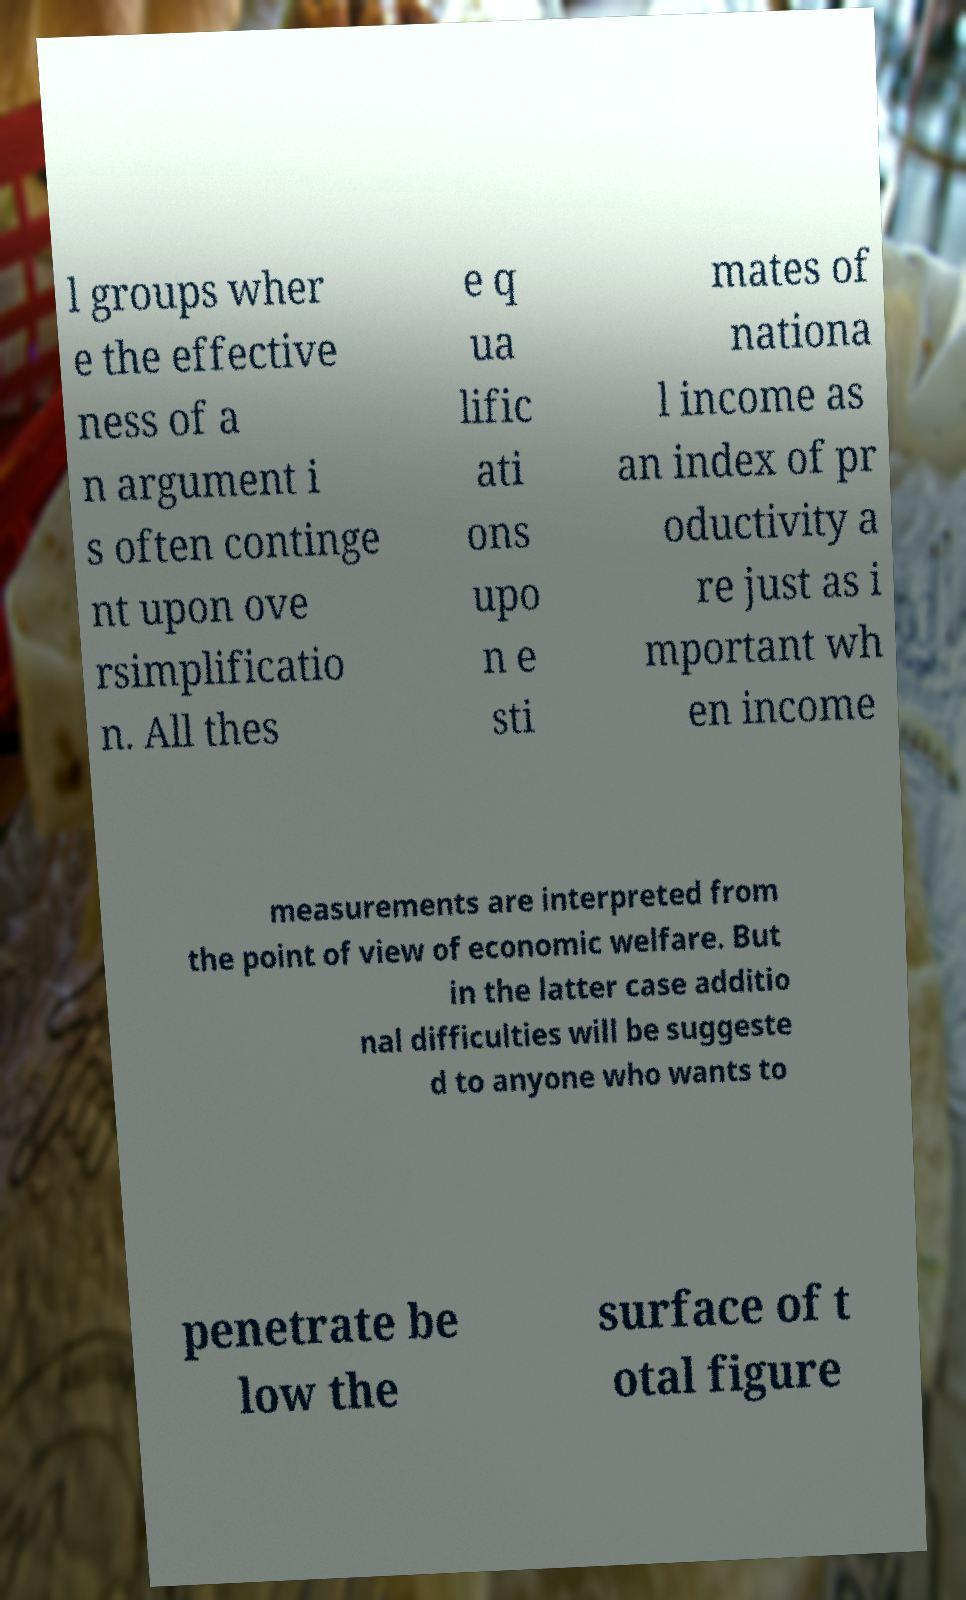Please read and relay the text visible in this image. What does it say? l groups wher e the effective ness of a n argument i s often continge nt upon ove rsimplificatio n. All thes e q ua lific ati ons upo n e sti mates of nationa l income as an index of pr oductivity a re just as i mportant wh en income measurements are interpreted from the point of view of economic welfare. But in the latter case additio nal difficulties will be suggeste d to anyone who wants to penetrate be low the surface of t otal figure 